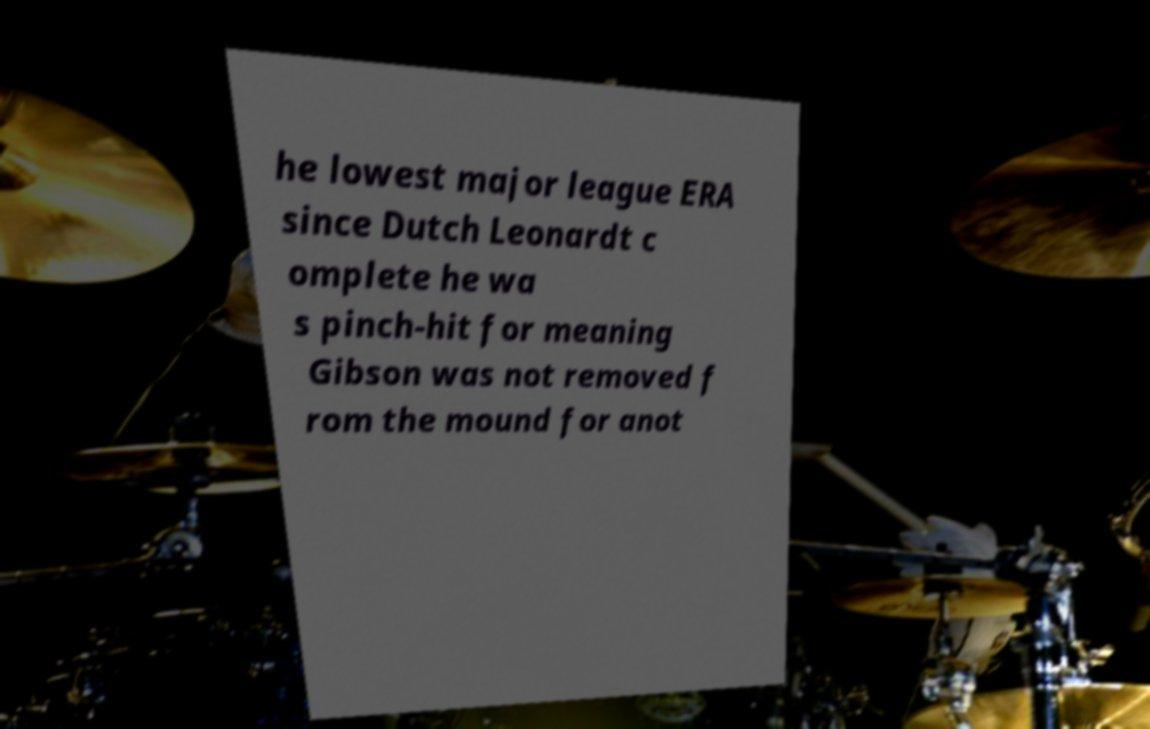Could you extract and type out the text from this image? he lowest major league ERA since Dutch Leonardt c omplete he wa s pinch-hit for meaning Gibson was not removed f rom the mound for anot 